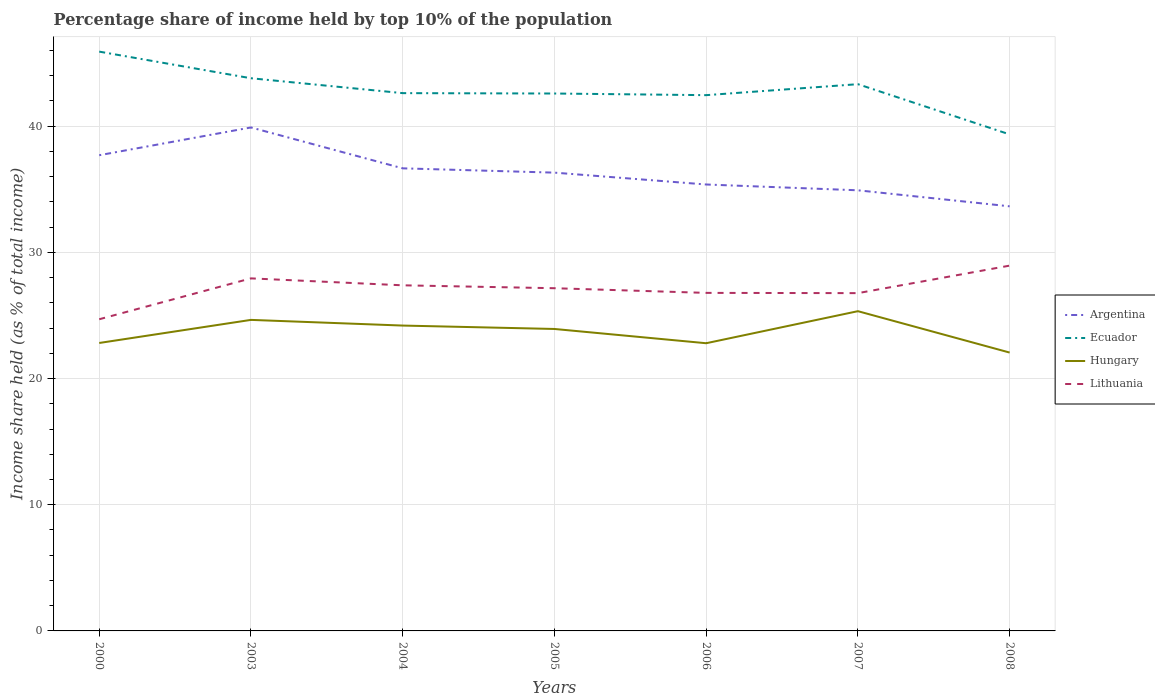How many different coloured lines are there?
Your answer should be very brief. 4. Does the line corresponding to Hungary intersect with the line corresponding to Ecuador?
Ensure brevity in your answer.  No. Across all years, what is the maximum percentage share of income held by top 10% of the population in Argentina?
Ensure brevity in your answer.  33.65. What is the total percentage share of income held by top 10% of the population in Lithuania in the graph?
Keep it short and to the point. -2.46. What is the difference between the highest and the second highest percentage share of income held by top 10% of the population in Hungary?
Offer a terse response. 3.28. What is the difference between the highest and the lowest percentage share of income held by top 10% of the population in Ecuador?
Your answer should be compact. 3. Is the percentage share of income held by top 10% of the population in Argentina strictly greater than the percentage share of income held by top 10% of the population in Ecuador over the years?
Make the answer very short. Yes. Are the values on the major ticks of Y-axis written in scientific E-notation?
Your answer should be compact. No. Does the graph contain any zero values?
Ensure brevity in your answer.  No. How are the legend labels stacked?
Your answer should be compact. Vertical. What is the title of the graph?
Your answer should be compact. Percentage share of income held by top 10% of the population. What is the label or title of the Y-axis?
Ensure brevity in your answer.  Income share held (as % of total income). What is the Income share held (as % of total income) in Argentina in 2000?
Make the answer very short. 37.7. What is the Income share held (as % of total income) in Ecuador in 2000?
Provide a succinct answer. 45.91. What is the Income share held (as % of total income) in Hungary in 2000?
Give a very brief answer. 22.82. What is the Income share held (as % of total income) in Lithuania in 2000?
Offer a terse response. 24.7. What is the Income share held (as % of total income) in Argentina in 2003?
Your response must be concise. 39.9. What is the Income share held (as % of total income) in Ecuador in 2003?
Keep it short and to the point. 43.8. What is the Income share held (as % of total income) of Hungary in 2003?
Your response must be concise. 24.65. What is the Income share held (as % of total income) of Lithuania in 2003?
Give a very brief answer. 27.94. What is the Income share held (as % of total income) of Argentina in 2004?
Give a very brief answer. 36.66. What is the Income share held (as % of total income) of Ecuador in 2004?
Ensure brevity in your answer.  42.62. What is the Income share held (as % of total income) in Hungary in 2004?
Your answer should be compact. 24.2. What is the Income share held (as % of total income) of Lithuania in 2004?
Offer a terse response. 27.39. What is the Income share held (as % of total income) in Argentina in 2005?
Your answer should be very brief. 36.32. What is the Income share held (as % of total income) in Ecuador in 2005?
Make the answer very short. 42.59. What is the Income share held (as % of total income) of Hungary in 2005?
Your answer should be compact. 23.93. What is the Income share held (as % of total income) of Lithuania in 2005?
Your answer should be compact. 27.16. What is the Income share held (as % of total income) of Argentina in 2006?
Your response must be concise. 35.38. What is the Income share held (as % of total income) of Ecuador in 2006?
Your response must be concise. 42.46. What is the Income share held (as % of total income) in Hungary in 2006?
Provide a short and direct response. 22.8. What is the Income share held (as % of total income) of Lithuania in 2006?
Offer a very short reply. 26.79. What is the Income share held (as % of total income) of Argentina in 2007?
Provide a short and direct response. 34.92. What is the Income share held (as % of total income) of Ecuador in 2007?
Give a very brief answer. 43.33. What is the Income share held (as % of total income) of Hungary in 2007?
Provide a succinct answer. 25.34. What is the Income share held (as % of total income) of Lithuania in 2007?
Your answer should be compact. 26.77. What is the Income share held (as % of total income) in Argentina in 2008?
Make the answer very short. 33.65. What is the Income share held (as % of total income) in Ecuador in 2008?
Provide a short and direct response. 39.35. What is the Income share held (as % of total income) in Hungary in 2008?
Offer a terse response. 22.06. What is the Income share held (as % of total income) of Lithuania in 2008?
Ensure brevity in your answer.  28.95. Across all years, what is the maximum Income share held (as % of total income) in Argentina?
Offer a terse response. 39.9. Across all years, what is the maximum Income share held (as % of total income) in Ecuador?
Offer a terse response. 45.91. Across all years, what is the maximum Income share held (as % of total income) of Hungary?
Your response must be concise. 25.34. Across all years, what is the maximum Income share held (as % of total income) in Lithuania?
Provide a short and direct response. 28.95. Across all years, what is the minimum Income share held (as % of total income) of Argentina?
Provide a short and direct response. 33.65. Across all years, what is the minimum Income share held (as % of total income) in Ecuador?
Give a very brief answer. 39.35. Across all years, what is the minimum Income share held (as % of total income) in Hungary?
Give a very brief answer. 22.06. Across all years, what is the minimum Income share held (as % of total income) of Lithuania?
Make the answer very short. 24.7. What is the total Income share held (as % of total income) in Argentina in the graph?
Provide a short and direct response. 254.53. What is the total Income share held (as % of total income) of Ecuador in the graph?
Your response must be concise. 300.06. What is the total Income share held (as % of total income) in Hungary in the graph?
Provide a succinct answer. 165.8. What is the total Income share held (as % of total income) of Lithuania in the graph?
Offer a very short reply. 189.7. What is the difference between the Income share held (as % of total income) in Ecuador in 2000 and that in 2003?
Your answer should be compact. 2.11. What is the difference between the Income share held (as % of total income) in Hungary in 2000 and that in 2003?
Ensure brevity in your answer.  -1.83. What is the difference between the Income share held (as % of total income) in Lithuania in 2000 and that in 2003?
Your answer should be very brief. -3.24. What is the difference between the Income share held (as % of total income) of Ecuador in 2000 and that in 2004?
Offer a very short reply. 3.29. What is the difference between the Income share held (as % of total income) in Hungary in 2000 and that in 2004?
Provide a succinct answer. -1.38. What is the difference between the Income share held (as % of total income) in Lithuania in 2000 and that in 2004?
Provide a succinct answer. -2.69. What is the difference between the Income share held (as % of total income) of Argentina in 2000 and that in 2005?
Give a very brief answer. 1.38. What is the difference between the Income share held (as % of total income) in Ecuador in 2000 and that in 2005?
Offer a very short reply. 3.32. What is the difference between the Income share held (as % of total income) in Hungary in 2000 and that in 2005?
Provide a short and direct response. -1.11. What is the difference between the Income share held (as % of total income) in Lithuania in 2000 and that in 2005?
Ensure brevity in your answer.  -2.46. What is the difference between the Income share held (as % of total income) in Argentina in 2000 and that in 2006?
Offer a terse response. 2.32. What is the difference between the Income share held (as % of total income) in Ecuador in 2000 and that in 2006?
Provide a succinct answer. 3.45. What is the difference between the Income share held (as % of total income) of Lithuania in 2000 and that in 2006?
Offer a very short reply. -2.09. What is the difference between the Income share held (as % of total income) in Argentina in 2000 and that in 2007?
Give a very brief answer. 2.78. What is the difference between the Income share held (as % of total income) of Ecuador in 2000 and that in 2007?
Your answer should be very brief. 2.58. What is the difference between the Income share held (as % of total income) in Hungary in 2000 and that in 2007?
Your response must be concise. -2.52. What is the difference between the Income share held (as % of total income) in Lithuania in 2000 and that in 2007?
Give a very brief answer. -2.07. What is the difference between the Income share held (as % of total income) of Argentina in 2000 and that in 2008?
Ensure brevity in your answer.  4.05. What is the difference between the Income share held (as % of total income) of Ecuador in 2000 and that in 2008?
Offer a very short reply. 6.56. What is the difference between the Income share held (as % of total income) of Hungary in 2000 and that in 2008?
Give a very brief answer. 0.76. What is the difference between the Income share held (as % of total income) in Lithuania in 2000 and that in 2008?
Ensure brevity in your answer.  -4.25. What is the difference between the Income share held (as % of total income) of Argentina in 2003 and that in 2004?
Ensure brevity in your answer.  3.24. What is the difference between the Income share held (as % of total income) in Ecuador in 2003 and that in 2004?
Give a very brief answer. 1.18. What is the difference between the Income share held (as % of total income) in Hungary in 2003 and that in 2004?
Provide a short and direct response. 0.45. What is the difference between the Income share held (as % of total income) of Lithuania in 2003 and that in 2004?
Ensure brevity in your answer.  0.55. What is the difference between the Income share held (as % of total income) in Argentina in 2003 and that in 2005?
Provide a succinct answer. 3.58. What is the difference between the Income share held (as % of total income) in Ecuador in 2003 and that in 2005?
Give a very brief answer. 1.21. What is the difference between the Income share held (as % of total income) of Hungary in 2003 and that in 2005?
Offer a very short reply. 0.72. What is the difference between the Income share held (as % of total income) in Lithuania in 2003 and that in 2005?
Provide a short and direct response. 0.78. What is the difference between the Income share held (as % of total income) in Argentina in 2003 and that in 2006?
Make the answer very short. 4.52. What is the difference between the Income share held (as % of total income) in Ecuador in 2003 and that in 2006?
Provide a short and direct response. 1.34. What is the difference between the Income share held (as % of total income) in Hungary in 2003 and that in 2006?
Offer a terse response. 1.85. What is the difference between the Income share held (as % of total income) of Lithuania in 2003 and that in 2006?
Your response must be concise. 1.15. What is the difference between the Income share held (as % of total income) in Argentina in 2003 and that in 2007?
Your answer should be compact. 4.98. What is the difference between the Income share held (as % of total income) in Ecuador in 2003 and that in 2007?
Your response must be concise. 0.47. What is the difference between the Income share held (as % of total income) of Hungary in 2003 and that in 2007?
Your answer should be compact. -0.69. What is the difference between the Income share held (as % of total income) of Lithuania in 2003 and that in 2007?
Keep it short and to the point. 1.17. What is the difference between the Income share held (as % of total income) of Argentina in 2003 and that in 2008?
Your response must be concise. 6.25. What is the difference between the Income share held (as % of total income) in Ecuador in 2003 and that in 2008?
Provide a succinct answer. 4.45. What is the difference between the Income share held (as % of total income) in Hungary in 2003 and that in 2008?
Ensure brevity in your answer.  2.59. What is the difference between the Income share held (as % of total income) of Lithuania in 2003 and that in 2008?
Your response must be concise. -1.01. What is the difference between the Income share held (as % of total income) of Argentina in 2004 and that in 2005?
Your answer should be compact. 0.34. What is the difference between the Income share held (as % of total income) of Hungary in 2004 and that in 2005?
Make the answer very short. 0.27. What is the difference between the Income share held (as % of total income) in Lithuania in 2004 and that in 2005?
Ensure brevity in your answer.  0.23. What is the difference between the Income share held (as % of total income) in Argentina in 2004 and that in 2006?
Ensure brevity in your answer.  1.28. What is the difference between the Income share held (as % of total income) in Ecuador in 2004 and that in 2006?
Offer a terse response. 0.16. What is the difference between the Income share held (as % of total income) of Lithuania in 2004 and that in 2006?
Give a very brief answer. 0.6. What is the difference between the Income share held (as % of total income) in Argentina in 2004 and that in 2007?
Ensure brevity in your answer.  1.74. What is the difference between the Income share held (as % of total income) in Ecuador in 2004 and that in 2007?
Make the answer very short. -0.71. What is the difference between the Income share held (as % of total income) of Hungary in 2004 and that in 2007?
Your answer should be compact. -1.14. What is the difference between the Income share held (as % of total income) in Lithuania in 2004 and that in 2007?
Offer a terse response. 0.62. What is the difference between the Income share held (as % of total income) in Argentina in 2004 and that in 2008?
Keep it short and to the point. 3.01. What is the difference between the Income share held (as % of total income) in Ecuador in 2004 and that in 2008?
Give a very brief answer. 3.27. What is the difference between the Income share held (as % of total income) in Hungary in 2004 and that in 2008?
Your answer should be very brief. 2.14. What is the difference between the Income share held (as % of total income) in Lithuania in 2004 and that in 2008?
Provide a short and direct response. -1.56. What is the difference between the Income share held (as % of total income) in Ecuador in 2005 and that in 2006?
Keep it short and to the point. 0.13. What is the difference between the Income share held (as % of total income) of Hungary in 2005 and that in 2006?
Make the answer very short. 1.13. What is the difference between the Income share held (as % of total income) of Lithuania in 2005 and that in 2006?
Provide a succinct answer. 0.37. What is the difference between the Income share held (as % of total income) in Ecuador in 2005 and that in 2007?
Offer a terse response. -0.74. What is the difference between the Income share held (as % of total income) of Hungary in 2005 and that in 2007?
Ensure brevity in your answer.  -1.41. What is the difference between the Income share held (as % of total income) of Lithuania in 2005 and that in 2007?
Your answer should be compact. 0.39. What is the difference between the Income share held (as % of total income) in Argentina in 2005 and that in 2008?
Ensure brevity in your answer.  2.67. What is the difference between the Income share held (as % of total income) in Ecuador in 2005 and that in 2008?
Your answer should be very brief. 3.24. What is the difference between the Income share held (as % of total income) of Hungary in 2005 and that in 2008?
Make the answer very short. 1.87. What is the difference between the Income share held (as % of total income) of Lithuania in 2005 and that in 2008?
Keep it short and to the point. -1.79. What is the difference between the Income share held (as % of total income) of Argentina in 2006 and that in 2007?
Provide a short and direct response. 0.46. What is the difference between the Income share held (as % of total income) in Ecuador in 2006 and that in 2007?
Provide a succinct answer. -0.87. What is the difference between the Income share held (as % of total income) of Hungary in 2006 and that in 2007?
Provide a short and direct response. -2.54. What is the difference between the Income share held (as % of total income) of Argentina in 2006 and that in 2008?
Give a very brief answer. 1.73. What is the difference between the Income share held (as % of total income) in Ecuador in 2006 and that in 2008?
Offer a very short reply. 3.11. What is the difference between the Income share held (as % of total income) of Hungary in 2006 and that in 2008?
Ensure brevity in your answer.  0.74. What is the difference between the Income share held (as % of total income) in Lithuania in 2006 and that in 2008?
Give a very brief answer. -2.16. What is the difference between the Income share held (as % of total income) in Argentina in 2007 and that in 2008?
Make the answer very short. 1.27. What is the difference between the Income share held (as % of total income) in Ecuador in 2007 and that in 2008?
Offer a very short reply. 3.98. What is the difference between the Income share held (as % of total income) in Hungary in 2007 and that in 2008?
Provide a short and direct response. 3.28. What is the difference between the Income share held (as % of total income) of Lithuania in 2007 and that in 2008?
Offer a terse response. -2.18. What is the difference between the Income share held (as % of total income) of Argentina in 2000 and the Income share held (as % of total income) of Ecuador in 2003?
Make the answer very short. -6.1. What is the difference between the Income share held (as % of total income) of Argentina in 2000 and the Income share held (as % of total income) of Hungary in 2003?
Your answer should be very brief. 13.05. What is the difference between the Income share held (as % of total income) in Argentina in 2000 and the Income share held (as % of total income) in Lithuania in 2003?
Provide a succinct answer. 9.76. What is the difference between the Income share held (as % of total income) in Ecuador in 2000 and the Income share held (as % of total income) in Hungary in 2003?
Make the answer very short. 21.26. What is the difference between the Income share held (as % of total income) in Ecuador in 2000 and the Income share held (as % of total income) in Lithuania in 2003?
Offer a terse response. 17.97. What is the difference between the Income share held (as % of total income) of Hungary in 2000 and the Income share held (as % of total income) of Lithuania in 2003?
Your response must be concise. -5.12. What is the difference between the Income share held (as % of total income) of Argentina in 2000 and the Income share held (as % of total income) of Ecuador in 2004?
Provide a succinct answer. -4.92. What is the difference between the Income share held (as % of total income) of Argentina in 2000 and the Income share held (as % of total income) of Lithuania in 2004?
Your answer should be compact. 10.31. What is the difference between the Income share held (as % of total income) in Ecuador in 2000 and the Income share held (as % of total income) in Hungary in 2004?
Make the answer very short. 21.71. What is the difference between the Income share held (as % of total income) in Ecuador in 2000 and the Income share held (as % of total income) in Lithuania in 2004?
Your answer should be compact. 18.52. What is the difference between the Income share held (as % of total income) of Hungary in 2000 and the Income share held (as % of total income) of Lithuania in 2004?
Provide a succinct answer. -4.57. What is the difference between the Income share held (as % of total income) in Argentina in 2000 and the Income share held (as % of total income) in Ecuador in 2005?
Ensure brevity in your answer.  -4.89. What is the difference between the Income share held (as % of total income) in Argentina in 2000 and the Income share held (as % of total income) in Hungary in 2005?
Give a very brief answer. 13.77. What is the difference between the Income share held (as % of total income) in Argentina in 2000 and the Income share held (as % of total income) in Lithuania in 2005?
Your response must be concise. 10.54. What is the difference between the Income share held (as % of total income) in Ecuador in 2000 and the Income share held (as % of total income) in Hungary in 2005?
Your response must be concise. 21.98. What is the difference between the Income share held (as % of total income) of Ecuador in 2000 and the Income share held (as % of total income) of Lithuania in 2005?
Offer a terse response. 18.75. What is the difference between the Income share held (as % of total income) of Hungary in 2000 and the Income share held (as % of total income) of Lithuania in 2005?
Provide a succinct answer. -4.34. What is the difference between the Income share held (as % of total income) of Argentina in 2000 and the Income share held (as % of total income) of Ecuador in 2006?
Make the answer very short. -4.76. What is the difference between the Income share held (as % of total income) in Argentina in 2000 and the Income share held (as % of total income) in Hungary in 2006?
Your answer should be very brief. 14.9. What is the difference between the Income share held (as % of total income) of Argentina in 2000 and the Income share held (as % of total income) of Lithuania in 2006?
Ensure brevity in your answer.  10.91. What is the difference between the Income share held (as % of total income) in Ecuador in 2000 and the Income share held (as % of total income) in Hungary in 2006?
Provide a succinct answer. 23.11. What is the difference between the Income share held (as % of total income) of Ecuador in 2000 and the Income share held (as % of total income) of Lithuania in 2006?
Offer a very short reply. 19.12. What is the difference between the Income share held (as % of total income) of Hungary in 2000 and the Income share held (as % of total income) of Lithuania in 2006?
Provide a succinct answer. -3.97. What is the difference between the Income share held (as % of total income) of Argentina in 2000 and the Income share held (as % of total income) of Ecuador in 2007?
Ensure brevity in your answer.  -5.63. What is the difference between the Income share held (as % of total income) in Argentina in 2000 and the Income share held (as % of total income) in Hungary in 2007?
Ensure brevity in your answer.  12.36. What is the difference between the Income share held (as % of total income) in Argentina in 2000 and the Income share held (as % of total income) in Lithuania in 2007?
Keep it short and to the point. 10.93. What is the difference between the Income share held (as % of total income) of Ecuador in 2000 and the Income share held (as % of total income) of Hungary in 2007?
Give a very brief answer. 20.57. What is the difference between the Income share held (as % of total income) of Ecuador in 2000 and the Income share held (as % of total income) of Lithuania in 2007?
Offer a very short reply. 19.14. What is the difference between the Income share held (as % of total income) of Hungary in 2000 and the Income share held (as % of total income) of Lithuania in 2007?
Keep it short and to the point. -3.95. What is the difference between the Income share held (as % of total income) of Argentina in 2000 and the Income share held (as % of total income) of Ecuador in 2008?
Your answer should be compact. -1.65. What is the difference between the Income share held (as % of total income) in Argentina in 2000 and the Income share held (as % of total income) in Hungary in 2008?
Provide a short and direct response. 15.64. What is the difference between the Income share held (as % of total income) of Argentina in 2000 and the Income share held (as % of total income) of Lithuania in 2008?
Provide a short and direct response. 8.75. What is the difference between the Income share held (as % of total income) of Ecuador in 2000 and the Income share held (as % of total income) of Hungary in 2008?
Make the answer very short. 23.85. What is the difference between the Income share held (as % of total income) in Ecuador in 2000 and the Income share held (as % of total income) in Lithuania in 2008?
Offer a very short reply. 16.96. What is the difference between the Income share held (as % of total income) of Hungary in 2000 and the Income share held (as % of total income) of Lithuania in 2008?
Your response must be concise. -6.13. What is the difference between the Income share held (as % of total income) of Argentina in 2003 and the Income share held (as % of total income) of Ecuador in 2004?
Offer a very short reply. -2.72. What is the difference between the Income share held (as % of total income) in Argentina in 2003 and the Income share held (as % of total income) in Lithuania in 2004?
Give a very brief answer. 12.51. What is the difference between the Income share held (as % of total income) of Ecuador in 2003 and the Income share held (as % of total income) of Hungary in 2004?
Ensure brevity in your answer.  19.6. What is the difference between the Income share held (as % of total income) in Ecuador in 2003 and the Income share held (as % of total income) in Lithuania in 2004?
Ensure brevity in your answer.  16.41. What is the difference between the Income share held (as % of total income) of Hungary in 2003 and the Income share held (as % of total income) of Lithuania in 2004?
Provide a short and direct response. -2.74. What is the difference between the Income share held (as % of total income) in Argentina in 2003 and the Income share held (as % of total income) in Ecuador in 2005?
Offer a terse response. -2.69. What is the difference between the Income share held (as % of total income) in Argentina in 2003 and the Income share held (as % of total income) in Hungary in 2005?
Offer a very short reply. 15.97. What is the difference between the Income share held (as % of total income) in Argentina in 2003 and the Income share held (as % of total income) in Lithuania in 2005?
Ensure brevity in your answer.  12.74. What is the difference between the Income share held (as % of total income) of Ecuador in 2003 and the Income share held (as % of total income) of Hungary in 2005?
Make the answer very short. 19.87. What is the difference between the Income share held (as % of total income) of Ecuador in 2003 and the Income share held (as % of total income) of Lithuania in 2005?
Make the answer very short. 16.64. What is the difference between the Income share held (as % of total income) in Hungary in 2003 and the Income share held (as % of total income) in Lithuania in 2005?
Your answer should be compact. -2.51. What is the difference between the Income share held (as % of total income) of Argentina in 2003 and the Income share held (as % of total income) of Ecuador in 2006?
Provide a succinct answer. -2.56. What is the difference between the Income share held (as % of total income) of Argentina in 2003 and the Income share held (as % of total income) of Hungary in 2006?
Your response must be concise. 17.1. What is the difference between the Income share held (as % of total income) in Argentina in 2003 and the Income share held (as % of total income) in Lithuania in 2006?
Give a very brief answer. 13.11. What is the difference between the Income share held (as % of total income) of Ecuador in 2003 and the Income share held (as % of total income) of Hungary in 2006?
Your answer should be compact. 21. What is the difference between the Income share held (as % of total income) in Ecuador in 2003 and the Income share held (as % of total income) in Lithuania in 2006?
Give a very brief answer. 17.01. What is the difference between the Income share held (as % of total income) of Hungary in 2003 and the Income share held (as % of total income) of Lithuania in 2006?
Provide a short and direct response. -2.14. What is the difference between the Income share held (as % of total income) in Argentina in 2003 and the Income share held (as % of total income) in Ecuador in 2007?
Keep it short and to the point. -3.43. What is the difference between the Income share held (as % of total income) in Argentina in 2003 and the Income share held (as % of total income) in Hungary in 2007?
Make the answer very short. 14.56. What is the difference between the Income share held (as % of total income) in Argentina in 2003 and the Income share held (as % of total income) in Lithuania in 2007?
Offer a terse response. 13.13. What is the difference between the Income share held (as % of total income) of Ecuador in 2003 and the Income share held (as % of total income) of Hungary in 2007?
Your answer should be compact. 18.46. What is the difference between the Income share held (as % of total income) of Ecuador in 2003 and the Income share held (as % of total income) of Lithuania in 2007?
Offer a very short reply. 17.03. What is the difference between the Income share held (as % of total income) in Hungary in 2003 and the Income share held (as % of total income) in Lithuania in 2007?
Your answer should be very brief. -2.12. What is the difference between the Income share held (as % of total income) of Argentina in 2003 and the Income share held (as % of total income) of Ecuador in 2008?
Offer a very short reply. 0.55. What is the difference between the Income share held (as % of total income) of Argentina in 2003 and the Income share held (as % of total income) of Hungary in 2008?
Provide a short and direct response. 17.84. What is the difference between the Income share held (as % of total income) of Argentina in 2003 and the Income share held (as % of total income) of Lithuania in 2008?
Keep it short and to the point. 10.95. What is the difference between the Income share held (as % of total income) in Ecuador in 2003 and the Income share held (as % of total income) in Hungary in 2008?
Provide a short and direct response. 21.74. What is the difference between the Income share held (as % of total income) in Ecuador in 2003 and the Income share held (as % of total income) in Lithuania in 2008?
Ensure brevity in your answer.  14.85. What is the difference between the Income share held (as % of total income) of Hungary in 2003 and the Income share held (as % of total income) of Lithuania in 2008?
Offer a very short reply. -4.3. What is the difference between the Income share held (as % of total income) in Argentina in 2004 and the Income share held (as % of total income) in Ecuador in 2005?
Offer a very short reply. -5.93. What is the difference between the Income share held (as % of total income) of Argentina in 2004 and the Income share held (as % of total income) of Hungary in 2005?
Ensure brevity in your answer.  12.73. What is the difference between the Income share held (as % of total income) in Argentina in 2004 and the Income share held (as % of total income) in Lithuania in 2005?
Offer a terse response. 9.5. What is the difference between the Income share held (as % of total income) in Ecuador in 2004 and the Income share held (as % of total income) in Hungary in 2005?
Your answer should be compact. 18.69. What is the difference between the Income share held (as % of total income) of Ecuador in 2004 and the Income share held (as % of total income) of Lithuania in 2005?
Your answer should be very brief. 15.46. What is the difference between the Income share held (as % of total income) in Hungary in 2004 and the Income share held (as % of total income) in Lithuania in 2005?
Give a very brief answer. -2.96. What is the difference between the Income share held (as % of total income) in Argentina in 2004 and the Income share held (as % of total income) in Hungary in 2006?
Give a very brief answer. 13.86. What is the difference between the Income share held (as % of total income) of Argentina in 2004 and the Income share held (as % of total income) of Lithuania in 2006?
Your answer should be compact. 9.87. What is the difference between the Income share held (as % of total income) of Ecuador in 2004 and the Income share held (as % of total income) of Hungary in 2006?
Ensure brevity in your answer.  19.82. What is the difference between the Income share held (as % of total income) of Ecuador in 2004 and the Income share held (as % of total income) of Lithuania in 2006?
Keep it short and to the point. 15.83. What is the difference between the Income share held (as % of total income) in Hungary in 2004 and the Income share held (as % of total income) in Lithuania in 2006?
Keep it short and to the point. -2.59. What is the difference between the Income share held (as % of total income) of Argentina in 2004 and the Income share held (as % of total income) of Ecuador in 2007?
Provide a short and direct response. -6.67. What is the difference between the Income share held (as % of total income) in Argentina in 2004 and the Income share held (as % of total income) in Hungary in 2007?
Offer a very short reply. 11.32. What is the difference between the Income share held (as % of total income) in Argentina in 2004 and the Income share held (as % of total income) in Lithuania in 2007?
Your answer should be very brief. 9.89. What is the difference between the Income share held (as % of total income) of Ecuador in 2004 and the Income share held (as % of total income) of Hungary in 2007?
Offer a very short reply. 17.28. What is the difference between the Income share held (as % of total income) of Ecuador in 2004 and the Income share held (as % of total income) of Lithuania in 2007?
Your response must be concise. 15.85. What is the difference between the Income share held (as % of total income) of Hungary in 2004 and the Income share held (as % of total income) of Lithuania in 2007?
Your response must be concise. -2.57. What is the difference between the Income share held (as % of total income) in Argentina in 2004 and the Income share held (as % of total income) in Ecuador in 2008?
Provide a succinct answer. -2.69. What is the difference between the Income share held (as % of total income) of Argentina in 2004 and the Income share held (as % of total income) of Hungary in 2008?
Make the answer very short. 14.6. What is the difference between the Income share held (as % of total income) in Argentina in 2004 and the Income share held (as % of total income) in Lithuania in 2008?
Make the answer very short. 7.71. What is the difference between the Income share held (as % of total income) of Ecuador in 2004 and the Income share held (as % of total income) of Hungary in 2008?
Keep it short and to the point. 20.56. What is the difference between the Income share held (as % of total income) in Ecuador in 2004 and the Income share held (as % of total income) in Lithuania in 2008?
Your response must be concise. 13.67. What is the difference between the Income share held (as % of total income) of Hungary in 2004 and the Income share held (as % of total income) of Lithuania in 2008?
Provide a short and direct response. -4.75. What is the difference between the Income share held (as % of total income) in Argentina in 2005 and the Income share held (as % of total income) in Ecuador in 2006?
Your answer should be compact. -6.14. What is the difference between the Income share held (as % of total income) of Argentina in 2005 and the Income share held (as % of total income) of Hungary in 2006?
Provide a succinct answer. 13.52. What is the difference between the Income share held (as % of total income) in Argentina in 2005 and the Income share held (as % of total income) in Lithuania in 2006?
Offer a terse response. 9.53. What is the difference between the Income share held (as % of total income) in Ecuador in 2005 and the Income share held (as % of total income) in Hungary in 2006?
Keep it short and to the point. 19.79. What is the difference between the Income share held (as % of total income) in Ecuador in 2005 and the Income share held (as % of total income) in Lithuania in 2006?
Offer a terse response. 15.8. What is the difference between the Income share held (as % of total income) in Hungary in 2005 and the Income share held (as % of total income) in Lithuania in 2006?
Your answer should be compact. -2.86. What is the difference between the Income share held (as % of total income) of Argentina in 2005 and the Income share held (as % of total income) of Ecuador in 2007?
Give a very brief answer. -7.01. What is the difference between the Income share held (as % of total income) of Argentina in 2005 and the Income share held (as % of total income) of Hungary in 2007?
Keep it short and to the point. 10.98. What is the difference between the Income share held (as % of total income) in Argentina in 2005 and the Income share held (as % of total income) in Lithuania in 2007?
Keep it short and to the point. 9.55. What is the difference between the Income share held (as % of total income) of Ecuador in 2005 and the Income share held (as % of total income) of Hungary in 2007?
Your answer should be very brief. 17.25. What is the difference between the Income share held (as % of total income) in Ecuador in 2005 and the Income share held (as % of total income) in Lithuania in 2007?
Ensure brevity in your answer.  15.82. What is the difference between the Income share held (as % of total income) in Hungary in 2005 and the Income share held (as % of total income) in Lithuania in 2007?
Provide a succinct answer. -2.84. What is the difference between the Income share held (as % of total income) of Argentina in 2005 and the Income share held (as % of total income) of Ecuador in 2008?
Keep it short and to the point. -3.03. What is the difference between the Income share held (as % of total income) of Argentina in 2005 and the Income share held (as % of total income) of Hungary in 2008?
Give a very brief answer. 14.26. What is the difference between the Income share held (as % of total income) of Argentina in 2005 and the Income share held (as % of total income) of Lithuania in 2008?
Offer a terse response. 7.37. What is the difference between the Income share held (as % of total income) of Ecuador in 2005 and the Income share held (as % of total income) of Hungary in 2008?
Offer a very short reply. 20.53. What is the difference between the Income share held (as % of total income) in Ecuador in 2005 and the Income share held (as % of total income) in Lithuania in 2008?
Offer a terse response. 13.64. What is the difference between the Income share held (as % of total income) in Hungary in 2005 and the Income share held (as % of total income) in Lithuania in 2008?
Your answer should be very brief. -5.02. What is the difference between the Income share held (as % of total income) of Argentina in 2006 and the Income share held (as % of total income) of Ecuador in 2007?
Offer a very short reply. -7.95. What is the difference between the Income share held (as % of total income) in Argentina in 2006 and the Income share held (as % of total income) in Hungary in 2007?
Your answer should be compact. 10.04. What is the difference between the Income share held (as % of total income) of Argentina in 2006 and the Income share held (as % of total income) of Lithuania in 2007?
Your answer should be compact. 8.61. What is the difference between the Income share held (as % of total income) of Ecuador in 2006 and the Income share held (as % of total income) of Hungary in 2007?
Ensure brevity in your answer.  17.12. What is the difference between the Income share held (as % of total income) in Ecuador in 2006 and the Income share held (as % of total income) in Lithuania in 2007?
Provide a short and direct response. 15.69. What is the difference between the Income share held (as % of total income) of Hungary in 2006 and the Income share held (as % of total income) of Lithuania in 2007?
Ensure brevity in your answer.  -3.97. What is the difference between the Income share held (as % of total income) of Argentina in 2006 and the Income share held (as % of total income) of Ecuador in 2008?
Offer a terse response. -3.97. What is the difference between the Income share held (as % of total income) in Argentina in 2006 and the Income share held (as % of total income) in Hungary in 2008?
Provide a succinct answer. 13.32. What is the difference between the Income share held (as % of total income) in Argentina in 2006 and the Income share held (as % of total income) in Lithuania in 2008?
Your answer should be very brief. 6.43. What is the difference between the Income share held (as % of total income) in Ecuador in 2006 and the Income share held (as % of total income) in Hungary in 2008?
Ensure brevity in your answer.  20.4. What is the difference between the Income share held (as % of total income) in Ecuador in 2006 and the Income share held (as % of total income) in Lithuania in 2008?
Your response must be concise. 13.51. What is the difference between the Income share held (as % of total income) of Hungary in 2006 and the Income share held (as % of total income) of Lithuania in 2008?
Your answer should be very brief. -6.15. What is the difference between the Income share held (as % of total income) in Argentina in 2007 and the Income share held (as % of total income) in Ecuador in 2008?
Your answer should be compact. -4.43. What is the difference between the Income share held (as % of total income) in Argentina in 2007 and the Income share held (as % of total income) in Hungary in 2008?
Offer a very short reply. 12.86. What is the difference between the Income share held (as % of total income) in Argentina in 2007 and the Income share held (as % of total income) in Lithuania in 2008?
Your answer should be very brief. 5.97. What is the difference between the Income share held (as % of total income) of Ecuador in 2007 and the Income share held (as % of total income) of Hungary in 2008?
Provide a succinct answer. 21.27. What is the difference between the Income share held (as % of total income) of Ecuador in 2007 and the Income share held (as % of total income) of Lithuania in 2008?
Offer a terse response. 14.38. What is the difference between the Income share held (as % of total income) in Hungary in 2007 and the Income share held (as % of total income) in Lithuania in 2008?
Your answer should be compact. -3.61. What is the average Income share held (as % of total income) of Argentina per year?
Make the answer very short. 36.36. What is the average Income share held (as % of total income) of Ecuador per year?
Keep it short and to the point. 42.87. What is the average Income share held (as % of total income) of Hungary per year?
Give a very brief answer. 23.69. What is the average Income share held (as % of total income) in Lithuania per year?
Ensure brevity in your answer.  27.1. In the year 2000, what is the difference between the Income share held (as % of total income) in Argentina and Income share held (as % of total income) in Ecuador?
Your answer should be compact. -8.21. In the year 2000, what is the difference between the Income share held (as % of total income) in Argentina and Income share held (as % of total income) in Hungary?
Your response must be concise. 14.88. In the year 2000, what is the difference between the Income share held (as % of total income) in Argentina and Income share held (as % of total income) in Lithuania?
Your answer should be very brief. 13. In the year 2000, what is the difference between the Income share held (as % of total income) of Ecuador and Income share held (as % of total income) of Hungary?
Your response must be concise. 23.09. In the year 2000, what is the difference between the Income share held (as % of total income) of Ecuador and Income share held (as % of total income) of Lithuania?
Keep it short and to the point. 21.21. In the year 2000, what is the difference between the Income share held (as % of total income) in Hungary and Income share held (as % of total income) in Lithuania?
Your answer should be very brief. -1.88. In the year 2003, what is the difference between the Income share held (as % of total income) in Argentina and Income share held (as % of total income) in Ecuador?
Make the answer very short. -3.9. In the year 2003, what is the difference between the Income share held (as % of total income) in Argentina and Income share held (as % of total income) in Hungary?
Provide a short and direct response. 15.25. In the year 2003, what is the difference between the Income share held (as % of total income) in Argentina and Income share held (as % of total income) in Lithuania?
Make the answer very short. 11.96. In the year 2003, what is the difference between the Income share held (as % of total income) in Ecuador and Income share held (as % of total income) in Hungary?
Provide a succinct answer. 19.15. In the year 2003, what is the difference between the Income share held (as % of total income) in Ecuador and Income share held (as % of total income) in Lithuania?
Make the answer very short. 15.86. In the year 2003, what is the difference between the Income share held (as % of total income) in Hungary and Income share held (as % of total income) in Lithuania?
Provide a succinct answer. -3.29. In the year 2004, what is the difference between the Income share held (as % of total income) in Argentina and Income share held (as % of total income) in Ecuador?
Your answer should be very brief. -5.96. In the year 2004, what is the difference between the Income share held (as % of total income) in Argentina and Income share held (as % of total income) in Hungary?
Your answer should be compact. 12.46. In the year 2004, what is the difference between the Income share held (as % of total income) of Argentina and Income share held (as % of total income) of Lithuania?
Provide a succinct answer. 9.27. In the year 2004, what is the difference between the Income share held (as % of total income) in Ecuador and Income share held (as % of total income) in Hungary?
Make the answer very short. 18.42. In the year 2004, what is the difference between the Income share held (as % of total income) of Ecuador and Income share held (as % of total income) of Lithuania?
Ensure brevity in your answer.  15.23. In the year 2004, what is the difference between the Income share held (as % of total income) in Hungary and Income share held (as % of total income) in Lithuania?
Offer a terse response. -3.19. In the year 2005, what is the difference between the Income share held (as % of total income) of Argentina and Income share held (as % of total income) of Ecuador?
Ensure brevity in your answer.  -6.27. In the year 2005, what is the difference between the Income share held (as % of total income) in Argentina and Income share held (as % of total income) in Hungary?
Make the answer very short. 12.39. In the year 2005, what is the difference between the Income share held (as % of total income) of Argentina and Income share held (as % of total income) of Lithuania?
Offer a terse response. 9.16. In the year 2005, what is the difference between the Income share held (as % of total income) in Ecuador and Income share held (as % of total income) in Hungary?
Make the answer very short. 18.66. In the year 2005, what is the difference between the Income share held (as % of total income) in Ecuador and Income share held (as % of total income) in Lithuania?
Provide a succinct answer. 15.43. In the year 2005, what is the difference between the Income share held (as % of total income) in Hungary and Income share held (as % of total income) in Lithuania?
Provide a short and direct response. -3.23. In the year 2006, what is the difference between the Income share held (as % of total income) of Argentina and Income share held (as % of total income) of Ecuador?
Make the answer very short. -7.08. In the year 2006, what is the difference between the Income share held (as % of total income) of Argentina and Income share held (as % of total income) of Hungary?
Offer a very short reply. 12.58. In the year 2006, what is the difference between the Income share held (as % of total income) of Argentina and Income share held (as % of total income) of Lithuania?
Your answer should be compact. 8.59. In the year 2006, what is the difference between the Income share held (as % of total income) in Ecuador and Income share held (as % of total income) in Hungary?
Provide a short and direct response. 19.66. In the year 2006, what is the difference between the Income share held (as % of total income) in Ecuador and Income share held (as % of total income) in Lithuania?
Your answer should be very brief. 15.67. In the year 2006, what is the difference between the Income share held (as % of total income) in Hungary and Income share held (as % of total income) in Lithuania?
Provide a short and direct response. -3.99. In the year 2007, what is the difference between the Income share held (as % of total income) in Argentina and Income share held (as % of total income) in Ecuador?
Provide a succinct answer. -8.41. In the year 2007, what is the difference between the Income share held (as % of total income) in Argentina and Income share held (as % of total income) in Hungary?
Offer a very short reply. 9.58. In the year 2007, what is the difference between the Income share held (as % of total income) of Argentina and Income share held (as % of total income) of Lithuania?
Keep it short and to the point. 8.15. In the year 2007, what is the difference between the Income share held (as % of total income) in Ecuador and Income share held (as % of total income) in Hungary?
Your response must be concise. 17.99. In the year 2007, what is the difference between the Income share held (as % of total income) in Ecuador and Income share held (as % of total income) in Lithuania?
Offer a terse response. 16.56. In the year 2007, what is the difference between the Income share held (as % of total income) in Hungary and Income share held (as % of total income) in Lithuania?
Offer a very short reply. -1.43. In the year 2008, what is the difference between the Income share held (as % of total income) in Argentina and Income share held (as % of total income) in Ecuador?
Your answer should be very brief. -5.7. In the year 2008, what is the difference between the Income share held (as % of total income) in Argentina and Income share held (as % of total income) in Hungary?
Ensure brevity in your answer.  11.59. In the year 2008, what is the difference between the Income share held (as % of total income) of Argentina and Income share held (as % of total income) of Lithuania?
Offer a terse response. 4.7. In the year 2008, what is the difference between the Income share held (as % of total income) in Ecuador and Income share held (as % of total income) in Hungary?
Give a very brief answer. 17.29. In the year 2008, what is the difference between the Income share held (as % of total income) in Hungary and Income share held (as % of total income) in Lithuania?
Your answer should be compact. -6.89. What is the ratio of the Income share held (as % of total income) in Argentina in 2000 to that in 2003?
Give a very brief answer. 0.94. What is the ratio of the Income share held (as % of total income) of Ecuador in 2000 to that in 2003?
Your answer should be compact. 1.05. What is the ratio of the Income share held (as % of total income) in Hungary in 2000 to that in 2003?
Give a very brief answer. 0.93. What is the ratio of the Income share held (as % of total income) in Lithuania in 2000 to that in 2003?
Your answer should be very brief. 0.88. What is the ratio of the Income share held (as % of total income) in Argentina in 2000 to that in 2004?
Give a very brief answer. 1.03. What is the ratio of the Income share held (as % of total income) of Ecuador in 2000 to that in 2004?
Give a very brief answer. 1.08. What is the ratio of the Income share held (as % of total income) in Hungary in 2000 to that in 2004?
Offer a very short reply. 0.94. What is the ratio of the Income share held (as % of total income) of Lithuania in 2000 to that in 2004?
Your answer should be compact. 0.9. What is the ratio of the Income share held (as % of total income) in Argentina in 2000 to that in 2005?
Offer a very short reply. 1.04. What is the ratio of the Income share held (as % of total income) of Ecuador in 2000 to that in 2005?
Provide a short and direct response. 1.08. What is the ratio of the Income share held (as % of total income) in Hungary in 2000 to that in 2005?
Offer a terse response. 0.95. What is the ratio of the Income share held (as % of total income) of Lithuania in 2000 to that in 2005?
Your answer should be compact. 0.91. What is the ratio of the Income share held (as % of total income) of Argentina in 2000 to that in 2006?
Your answer should be compact. 1.07. What is the ratio of the Income share held (as % of total income) in Ecuador in 2000 to that in 2006?
Give a very brief answer. 1.08. What is the ratio of the Income share held (as % of total income) in Hungary in 2000 to that in 2006?
Your answer should be compact. 1. What is the ratio of the Income share held (as % of total income) of Lithuania in 2000 to that in 2006?
Offer a very short reply. 0.92. What is the ratio of the Income share held (as % of total income) of Argentina in 2000 to that in 2007?
Your answer should be very brief. 1.08. What is the ratio of the Income share held (as % of total income) in Ecuador in 2000 to that in 2007?
Give a very brief answer. 1.06. What is the ratio of the Income share held (as % of total income) in Hungary in 2000 to that in 2007?
Offer a terse response. 0.9. What is the ratio of the Income share held (as % of total income) of Lithuania in 2000 to that in 2007?
Your response must be concise. 0.92. What is the ratio of the Income share held (as % of total income) in Argentina in 2000 to that in 2008?
Provide a short and direct response. 1.12. What is the ratio of the Income share held (as % of total income) of Ecuador in 2000 to that in 2008?
Offer a very short reply. 1.17. What is the ratio of the Income share held (as % of total income) of Hungary in 2000 to that in 2008?
Make the answer very short. 1.03. What is the ratio of the Income share held (as % of total income) in Lithuania in 2000 to that in 2008?
Your answer should be compact. 0.85. What is the ratio of the Income share held (as % of total income) of Argentina in 2003 to that in 2004?
Ensure brevity in your answer.  1.09. What is the ratio of the Income share held (as % of total income) in Ecuador in 2003 to that in 2004?
Your answer should be very brief. 1.03. What is the ratio of the Income share held (as % of total income) in Hungary in 2003 to that in 2004?
Your answer should be compact. 1.02. What is the ratio of the Income share held (as % of total income) in Lithuania in 2003 to that in 2004?
Give a very brief answer. 1.02. What is the ratio of the Income share held (as % of total income) of Argentina in 2003 to that in 2005?
Provide a succinct answer. 1.1. What is the ratio of the Income share held (as % of total income) of Ecuador in 2003 to that in 2005?
Ensure brevity in your answer.  1.03. What is the ratio of the Income share held (as % of total income) of Hungary in 2003 to that in 2005?
Offer a very short reply. 1.03. What is the ratio of the Income share held (as % of total income) in Lithuania in 2003 to that in 2005?
Give a very brief answer. 1.03. What is the ratio of the Income share held (as % of total income) in Argentina in 2003 to that in 2006?
Keep it short and to the point. 1.13. What is the ratio of the Income share held (as % of total income) in Ecuador in 2003 to that in 2006?
Ensure brevity in your answer.  1.03. What is the ratio of the Income share held (as % of total income) in Hungary in 2003 to that in 2006?
Your response must be concise. 1.08. What is the ratio of the Income share held (as % of total income) of Lithuania in 2003 to that in 2006?
Ensure brevity in your answer.  1.04. What is the ratio of the Income share held (as % of total income) in Argentina in 2003 to that in 2007?
Provide a short and direct response. 1.14. What is the ratio of the Income share held (as % of total income) of Ecuador in 2003 to that in 2007?
Offer a terse response. 1.01. What is the ratio of the Income share held (as % of total income) of Hungary in 2003 to that in 2007?
Provide a short and direct response. 0.97. What is the ratio of the Income share held (as % of total income) in Lithuania in 2003 to that in 2007?
Provide a succinct answer. 1.04. What is the ratio of the Income share held (as % of total income) of Argentina in 2003 to that in 2008?
Offer a terse response. 1.19. What is the ratio of the Income share held (as % of total income) of Ecuador in 2003 to that in 2008?
Give a very brief answer. 1.11. What is the ratio of the Income share held (as % of total income) in Hungary in 2003 to that in 2008?
Make the answer very short. 1.12. What is the ratio of the Income share held (as % of total income) in Lithuania in 2003 to that in 2008?
Offer a very short reply. 0.97. What is the ratio of the Income share held (as % of total income) of Argentina in 2004 to that in 2005?
Give a very brief answer. 1.01. What is the ratio of the Income share held (as % of total income) of Hungary in 2004 to that in 2005?
Provide a short and direct response. 1.01. What is the ratio of the Income share held (as % of total income) of Lithuania in 2004 to that in 2005?
Make the answer very short. 1.01. What is the ratio of the Income share held (as % of total income) in Argentina in 2004 to that in 2006?
Give a very brief answer. 1.04. What is the ratio of the Income share held (as % of total income) in Ecuador in 2004 to that in 2006?
Your response must be concise. 1. What is the ratio of the Income share held (as % of total income) of Hungary in 2004 to that in 2006?
Ensure brevity in your answer.  1.06. What is the ratio of the Income share held (as % of total income) in Lithuania in 2004 to that in 2006?
Give a very brief answer. 1.02. What is the ratio of the Income share held (as % of total income) of Argentina in 2004 to that in 2007?
Provide a succinct answer. 1.05. What is the ratio of the Income share held (as % of total income) of Ecuador in 2004 to that in 2007?
Keep it short and to the point. 0.98. What is the ratio of the Income share held (as % of total income) of Hungary in 2004 to that in 2007?
Offer a very short reply. 0.95. What is the ratio of the Income share held (as % of total income) in Lithuania in 2004 to that in 2007?
Provide a succinct answer. 1.02. What is the ratio of the Income share held (as % of total income) in Argentina in 2004 to that in 2008?
Provide a short and direct response. 1.09. What is the ratio of the Income share held (as % of total income) in Ecuador in 2004 to that in 2008?
Make the answer very short. 1.08. What is the ratio of the Income share held (as % of total income) of Hungary in 2004 to that in 2008?
Your answer should be very brief. 1.1. What is the ratio of the Income share held (as % of total income) of Lithuania in 2004 to that in 2008?
Keep it short and to the point. 0.95. What is the ratio of the Income share held (as % of total income) in Argentina in 2005 to that in 2006?
Ensure brevity in your answer.  1.03. What is the ratio of the Income share held (as % of total income) of Ecuador in 2005 to that in 2006?
Provide a short and direct response. 1. What is the ratio of the Income share held (as % of total income) in Hungary in 2005 to that in 2006?
Ensure brevity in your answer.  1.05. What is the ratio of the Income share held (as % of total income) in Lithuania in 2005 to that in 2006?
Offer a very short reply. 1.01. What is the ratio of the Income share held (as % of total income) in Argentina in 2005 to that in 2007?
Ensure brevity in your answer.  1.04. What is the ratio of the Income share held (as % of total income) of Ecuador in 2005 to that in 2007?
Make the answer very short. 0.98. What is the ratio of the Income share held (as % of total income) in Lithuania in 2005 to that in 2007?
Provide a short and direct response. 1.01. What is the ratio of the Income share held (as % of total income) in Argentina in 2005 to that in 2008?
Provide a succinct answer. 1.08. What is the ratio of the Income share held (as % of total income) of Ecuador in 2005 to that in 2008?
Your response must be concise. 1.08. What is the ratio of the Income share held (as % of total income) in Hungary in 2005 to that in 2008?
Provide a succinct answer. 1.08. What is the ratio of the Income share held (as % of total income) in Lithuania in 2005 to that in 2008?
Your answer should be compact. 0.94. What is the ratio of the Income share held (as % of total income) of Argentina in 2006 to that in 2007?
Provide a short and direct response. 1.01. What is the ratio of the Income share held (as % of total income) of Ecuador in 2006 to that in 2007?
Provide a short and direct response. 0.98. What is the ratio of the Income share held (as % of total income) in Hungary in 2006 to that in 2007?
Make the answer very short. 0.9. What is the ratio of the Income share held (as % of total income) in Lithuania in 2006 to that in 2007?
Make the answer very short. 1. What is the ratio of the Income share held (as % of total income) of Argentina in 2006 to that in 2008?
Provide a short and direct response. 1.05. What is the ratio of the Income share held (as % of total income) of Ecuador in 2006 to that in 2008?
Provide a succinct answer. 1.08. What is the ratio of the Income share held (as % of total income) in Hungary in 2006 to that in 2008?
Provide a succinct answer. 1.03. What is the ratio of the Income share held (as % of total income) of Lithuania in 2006 to that in 2008?
Your response must be concise. 0.93. What is the ratio of the Income share held (as % of total income) of Argentina in 2007 to that in 2008?
Your answer should be very brief. 1.04. What is the ratio of the Income share held (as % of total income) of Ecuador in 2007 to that in 2008?
Provide a succinct answer. 1.1. What is the ratio of the Income share held (as % of total income) in Hungary in 2007 to that in 2008?
Offer a terse response. 1.15. What is the ratio of the Income share held (as % of total income) of Lithuania in 2007 to that in 2008?
Provide a succinct answer. 0.92. What is the difference between the highest and the second highest Income share held (as % of total income) of Argentina?
Offer a very short reply. 2.2. What is the difference between the highest and the second highest Income share held (as % of total income) in Ecuador?
Make the answer very short. 2.11. What is the difference between the highest and the second highest Income share held (as % of total income) in Hungary?
Ensure brevity in your answer.  0.69. What is the difference between the highest and the lowest Income share held (as % of total income) in Argentina?
Make the answer very short. 6.25. What is the difference between the highest and the lowest Income share held (as % of total income) in Ecuador?
Provide a succinct answer. 6.56. What is the difference between the highest and the lowest Income share held (as % of total income) in Hungary?
Your response must be concise. 3.28. What is the difference between the highest and the lowest Income share held (as % of total income) of Lithuania?
Make the answer very short. 4.25. 